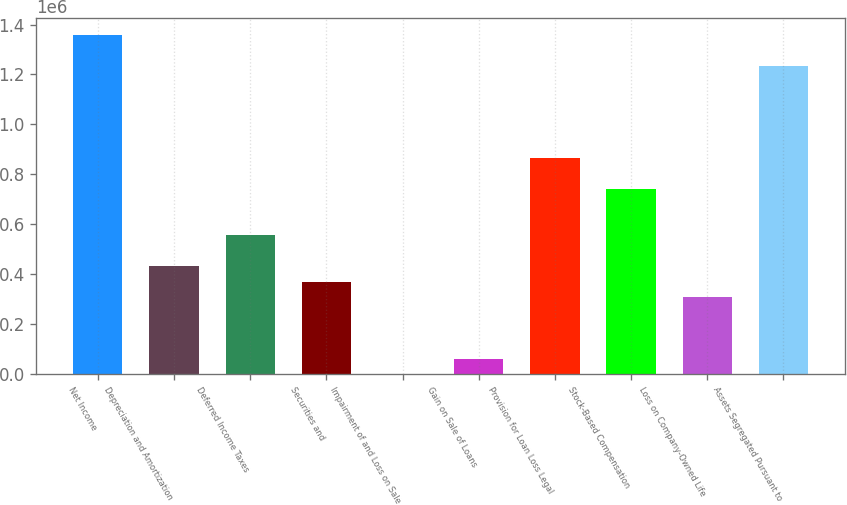<chart> <loc_0><loc_0><loc_500><loc_500><bar_chart><fcel>Net Income<fcel>Depreciation and Amortization<fcel>Deferred Income Taxes<fcel>Securities and<fcel>Impairment of and Loss on Sale<fcel>Gain on Sale of Loans<fcel>Provision for Loan Loss Legal<fcel>Stock-Based Compensation<fcel>Loss on Company-Owned Life<fcel>Assets Segregated Pursuant to<nl><fcel>1.35776e+06<fcel>432040<fcel>555470<fcel>370325<fcel>36<fcel>61750.9<fcel>864045<fcel>740615<fcel>308610<fcel>1.23433e+06<nl></chart> 